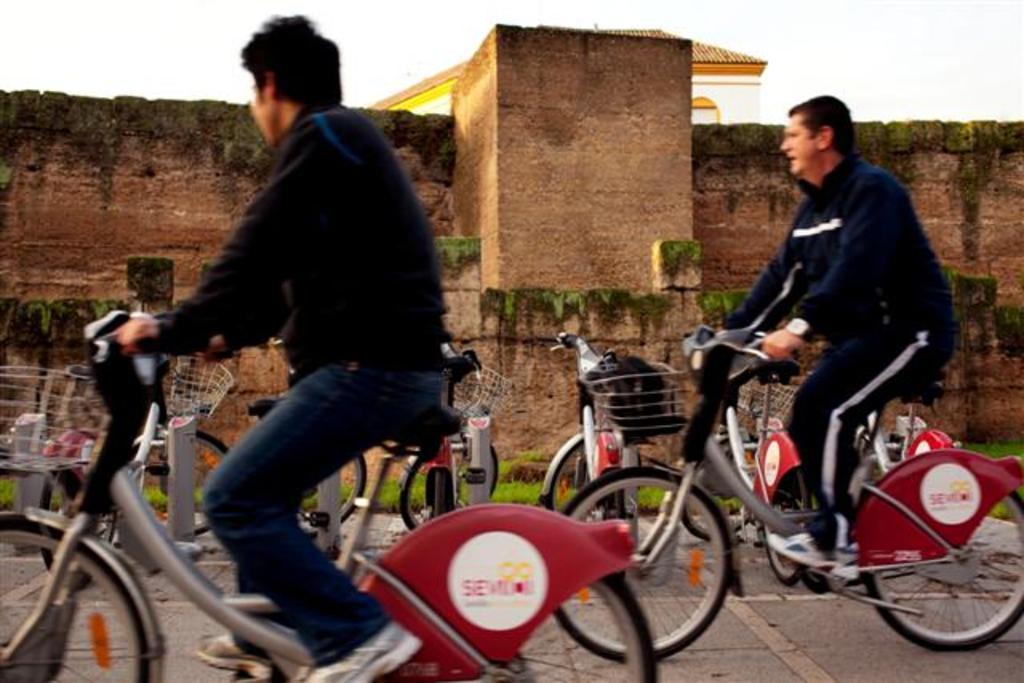Can you describe this image briefly? This picture is of outside. In the foreground there are two persons riding bicycles and there are many bicycles standing on the ground. In the background we can see the sky, buildings and the grass. 